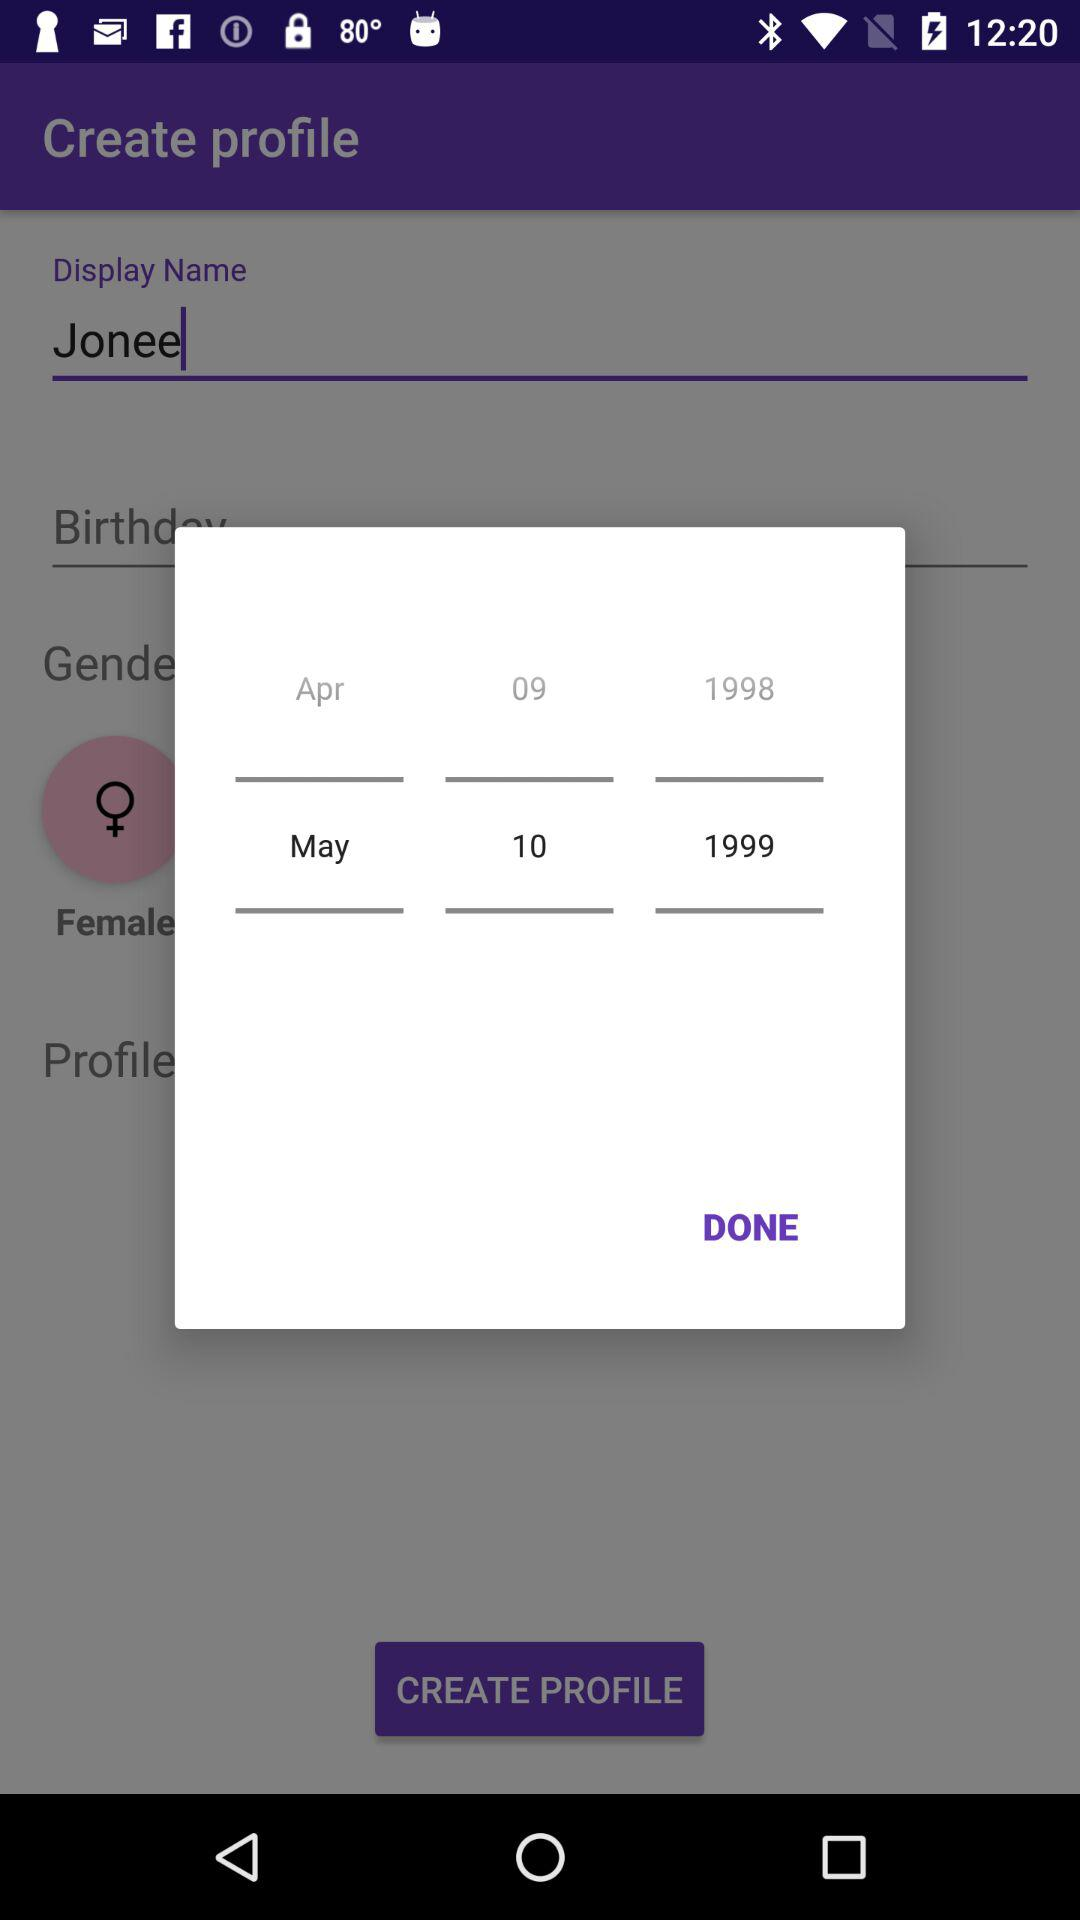Which day of the week falls on May 10, 1999?
When the provided information is insufficient, respond with <no answer>. <no answer> 